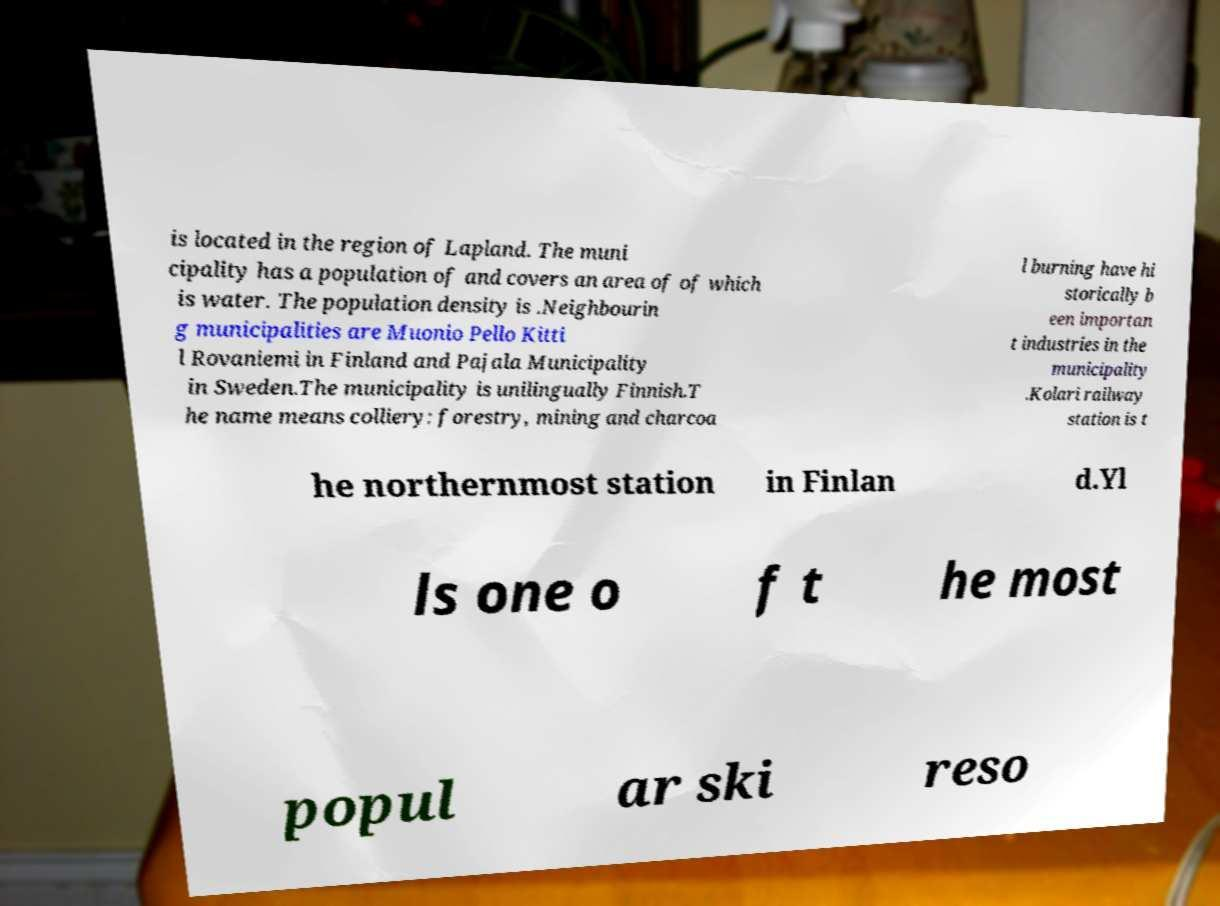There's text embedded in this image that I need extracted. Can you transcribe it verbatim? is located in the region of Lapland. The muni cipality has a population of and covers an area of of which is water. The population density is .Neighbourin g municipalities are Muonio Pello Kitti l Rovaniemi in Finland and Pajala Municipality in Sweden.The municipality is unilingually Finnish.T he name means colliery: forestry, mining and charcoa l burning have hi storically b een importan t industries in the municipality .Kolari railway station is t he northernmost station in Finlan d.Yl ls one o f t he most popul ar ski reso 